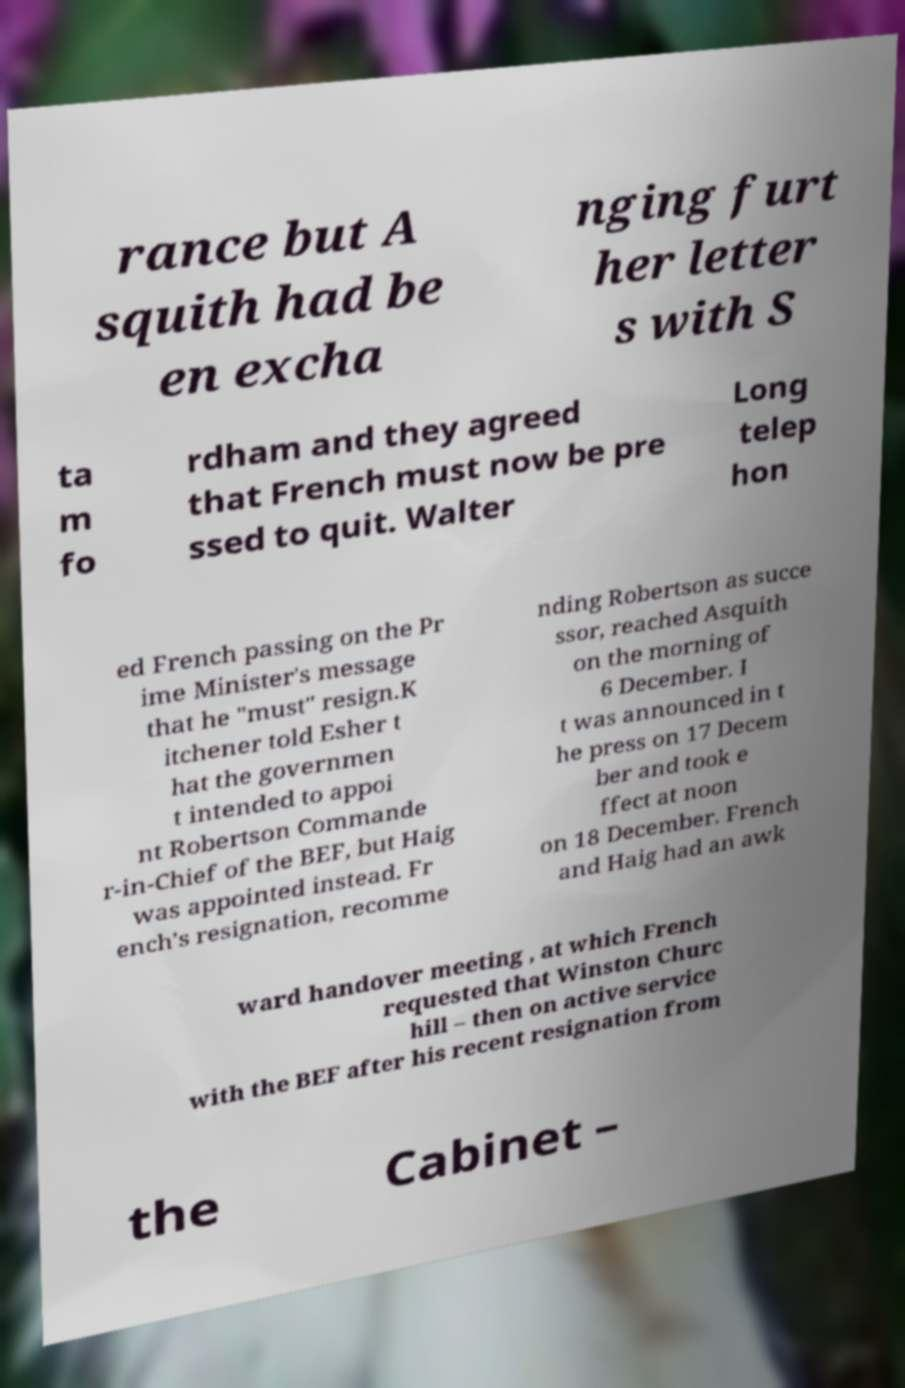Can you read and provide the text displayed in the image?This photo seems to have some interesting text. Can you extract and type it out for me? rance but A squith had be en excha nging furt her letter s with S ta m fo rdham and they agreed that French must now be pre ssed to quit. Walter Long telep hon ed French passing on the Pr ime Minister's message that he "must" resign.K itchener told Esher t hat the governmen t intended to appoi nt Robertson Commande r-in-Chief of the BEF, but Haig was appointed instead. Fr ench's resignation, recomme nding Robertson as succe ssor, reached Asquith on the morning of 6 December. I t was announced in t he press on 17 Decem ber and took e ffect at noon on 18 December. French and Haig had an awk ward handover meeting , at which French requested that Winston Churc hill – then on active service with the BEF after his recent resignation from the Cabinet – 